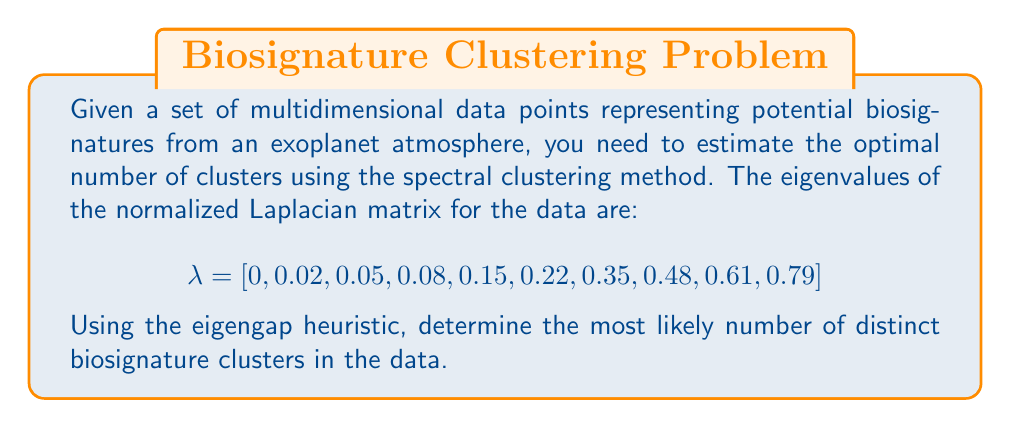Provide a solution to this math problem. To estimate the optimal number of clusters using the eigengap heuristic in spectral clustering, we follow these steps:

1. The eigenvalues are already provided and sorted in ascending order.

2. Calculate the differences (gaps) between consecutive eigenvalues:
   $$\begin{align}
   \text{gap}_1 &= 0.02 - 0 = 0.02 \\
   \text{gap}_2 &= 0.05 - 0.02 = 0.03 \\
   \text{gap}_3 &= 0.08 - 0.05 = 0.03 \\
   \text{gap}_4 &= 0.15 - 0.08 = 0.07 \\
   \text{gap}_5 &= 0.22 - 0.15 = 0.07 \\
   \text{gap}_6 &= 0.35 - 0.22 = 0.13 \\
   \text{gap}_7 &= 0.48 - 0.35 = 0.13 \\
   \text{gap}_8 &= 0.61 - 0.48 = 0.13 \\
   \text{gap}_9 &= 0.79 - 0.61 = 0.18
   \end{align}$$

3. Identify the largest gap. In this case, the largest gap is $\text{gap}_9 = 0.18$.

4. The optimal number of clusters is given by the index of the largest gap. Since the largest gap is at index 9, the optimal number of clusters is 9.

This suggests that there are likely 9 distinct biosignature clusters in the data.
Answer: 9 clusters 